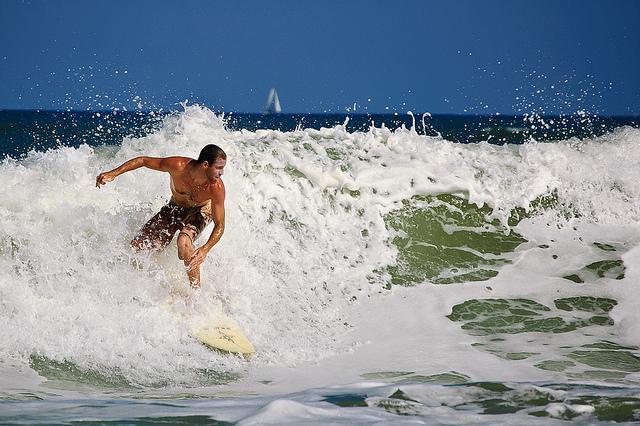How many boats are in the background?
Give a very brief answer. 1. How many dogs are there?
Give a very brief answer. 0. 